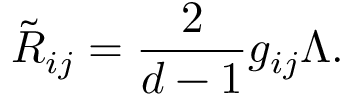<formula> <loc_0><loc_0><loc_500><loc_500>\tilde { R } _ { i j } = \frac { 2 } d - 1 } g _ { i j } \Lambda .</formula> 